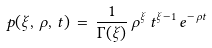<formula> <loc_0><loc_0><loc_500><loc_500>p ( \xi , \, \rho , \, t ) \, = \, \frac { 1 } { \Gamma ( \xi ) } \, \rho ^ { \xi } \, t ^ { \xi - 1 } \, e ^ { - \, \rho t }</formula> 